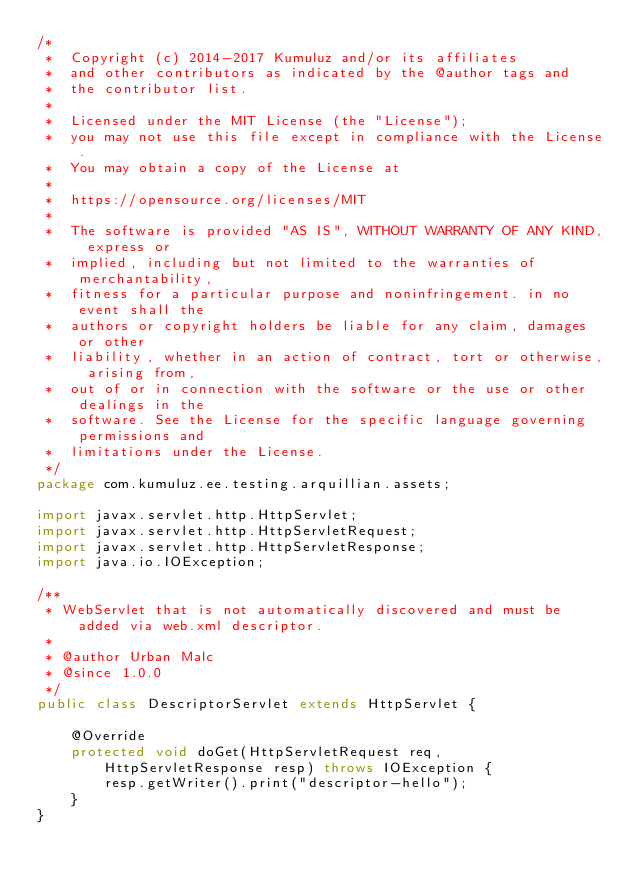<code> <loc_0><loc_0><loc_500><loc_500><_Java_>/*
 *  Copyright (c) 2014-2017 Kumuluz and/or its affiliates
 *  and other contributors as indicated by the @author tags and
 *  the contributor list.
 *
 *  Licensed under the MIT License (the "License");
 *  you may not use this file except in compliance with the License.
 *  You may obtain a copy of the License at
 *
 *  https://opensource.org/licenses/MIT
 *
 *  The software is provided "AS IS", WITHOUT WARRANTY OF ANY KIND, express or
 *  implied, including but not limited to the warranties of merchantability,
 *  fitness for a particular purpose and noninfringement. in no event shall the
 *  authors or copyright holders be liable for any claim, damages or other
 *  liability, whether in an action of contract, tort or otherwise, arising from,
 *  out of or in connection with the software or the use or other dealings in the
 *  software. See the License for the specific language governing permissions and
 *  limitations under the License.
 */
package com.kumuluz.ee.testing.arquillian.assets;

import javax.servlet.http.HttpServlet;
import javax.servlet.http.HttpServletRequest;
import javax.servlet.http.HttpServletResponse;
import java.io.IOException;

/**
 * WebServlet that is not automatically discovered and must be added via web.xml descriptor.
 *
 * @author Urban Malc
 * @since 1.0.0
 */
public class DescriptorServlet extends HttpServlet {

    @Override
    protected void doGet(HttpServletRequest req, HttpServletResponse resp) throws IOException {
        resp.getWriter().print("descriptor-hello");
    }
}
</code> 